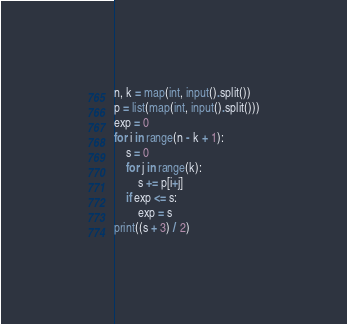<code> <loc_0><loc_0><loc_500><loc_500><_Python_>n, k = map(int, input().split())
p = list(map(int, input().split()))
exp = 0
for i in range(n - k + 1):
    s = 0
    for j in range(k):
        s += p[i+j]
    if exp <= s:
        exp = s
print((s + 3) / 2)
</code> 